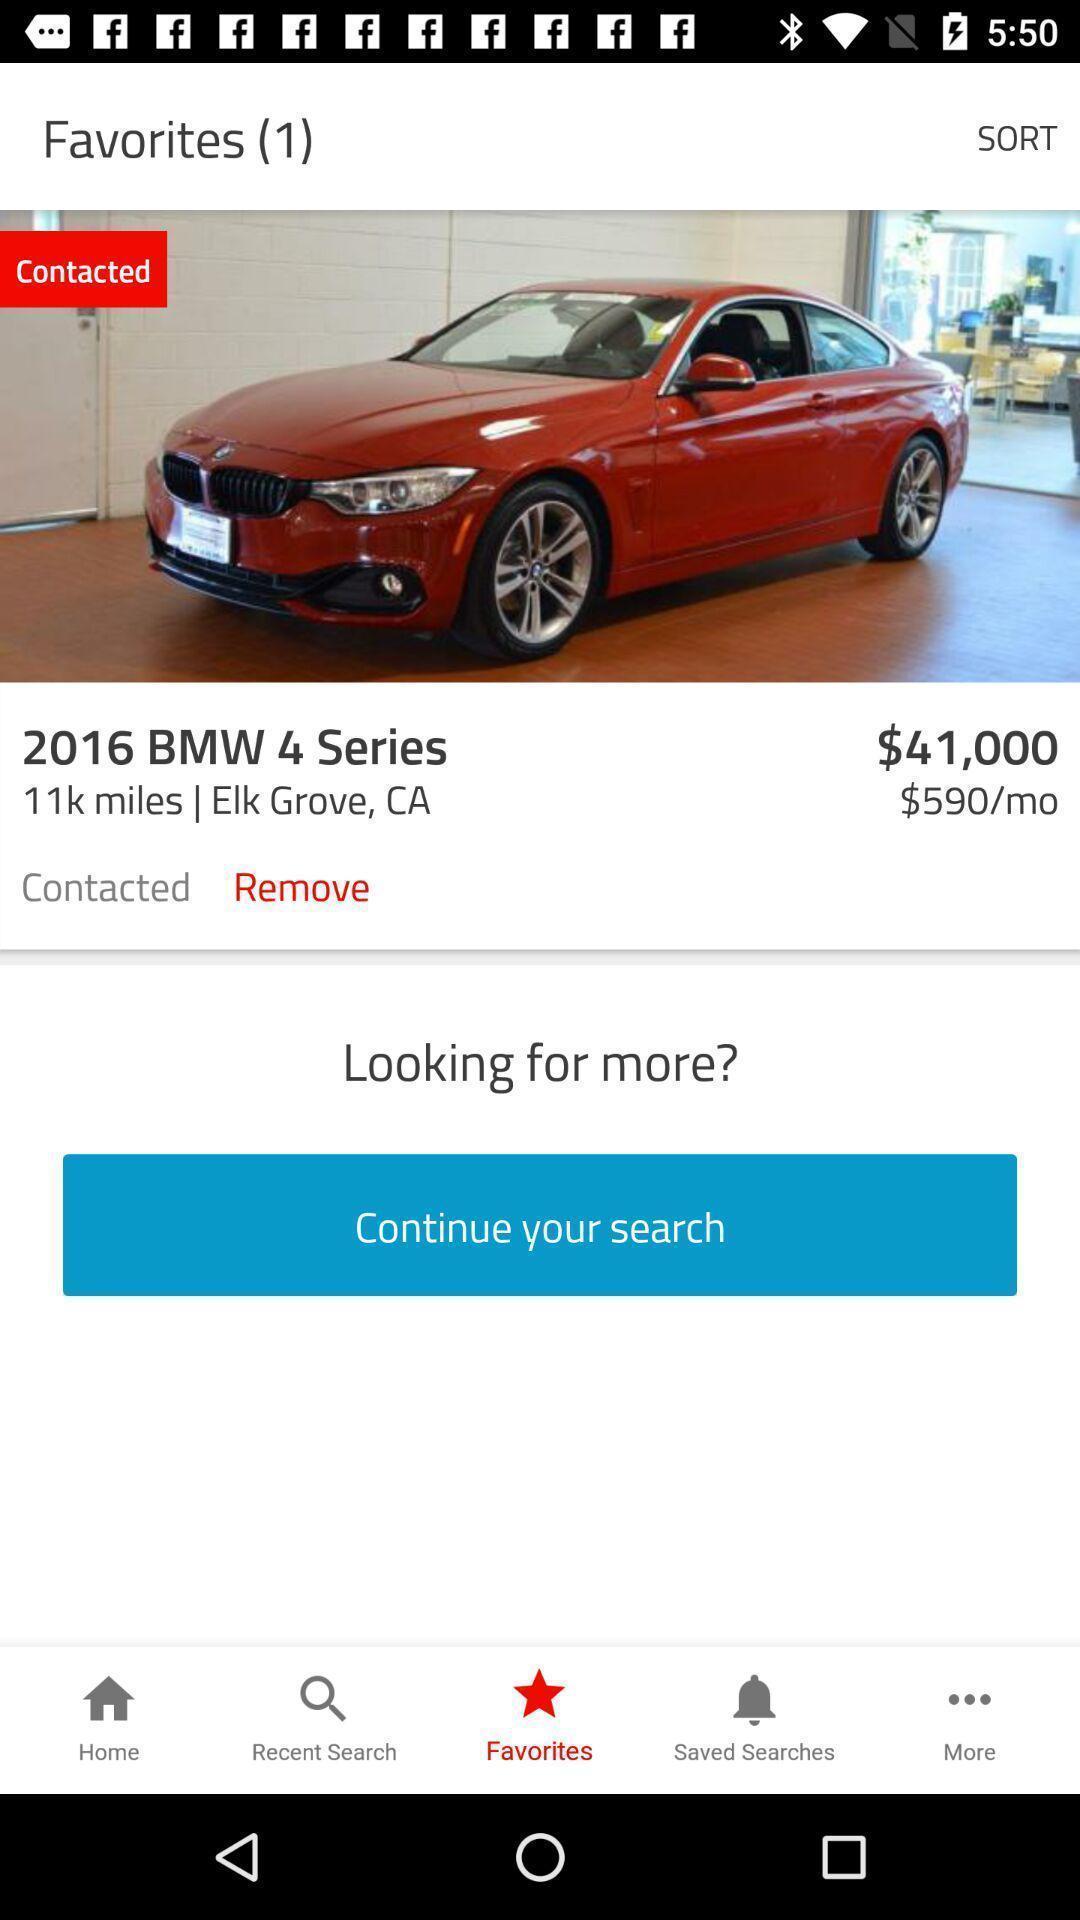Describe the key features of this screenshot. Result page showing favorite car details in a shopping app. 